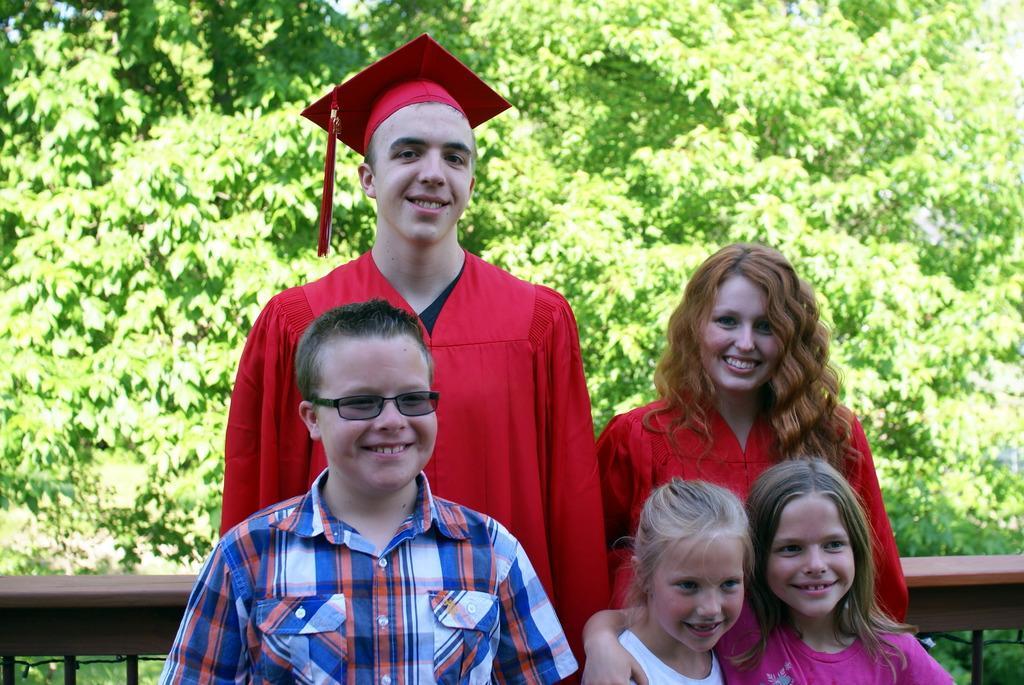Please provide a concise description of this image. In this picture I can see five persons smiling, there is a kind of fence, and in the background there are trees. 